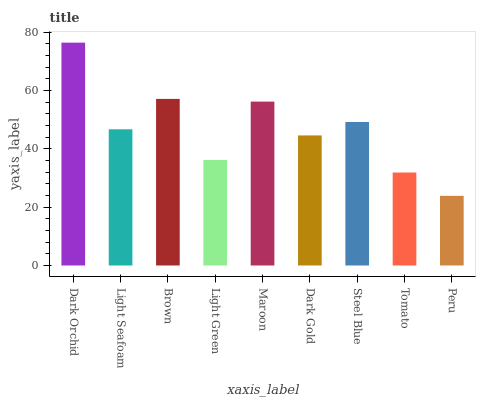Is Peru the minimum?
Answer yes or no. Yes. Is Dark Orchid the maximum?
Answer yes or no. Yes. Is Light Seafoam the minimum?
Answer yes or no. No. Is Light Seafoam the maximum?
Answer yes or no. No. Is Dark Orchid greater than Light Seafoam?
Answer yes or no. Yes. Is Light Seafoam less than Dark Orchid?
Answer yes or no. Yes. Is Light Seafoam greater than Dark Orchid?
Answer yes or no. No. Is Dark Orchid less than Light Seafoam?
Answer yes or no. No. Is Light Seafoam the high median?
Answer yes or no. Yes. Is Light Seafoam the low median?
Answer yes or no. Yes. Is Maroon the high median?
Answer yes or no. No. Is Brown the low median?
Answer yes or no. No. 